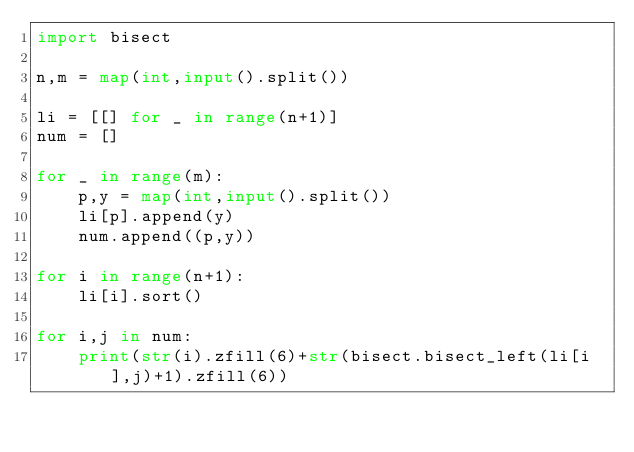Convert code to text. <code><loc_0><loc_0><loc_500><loc_500><_Python_>import bisect

n,m = map(int,input().split())

li = [[] for _ in range(n+1)]
num = []

for _ in range(m):
    p,y = map(int,input().split())
    li[p].append(y)
    num.append((p,y))

for i in range(n+1):
    li[i].sort()

for i,j in num:
    print(str(i).zfill(6)+str(bisect.bisect_left(li[i],j)+1).zfill(6))</code> 